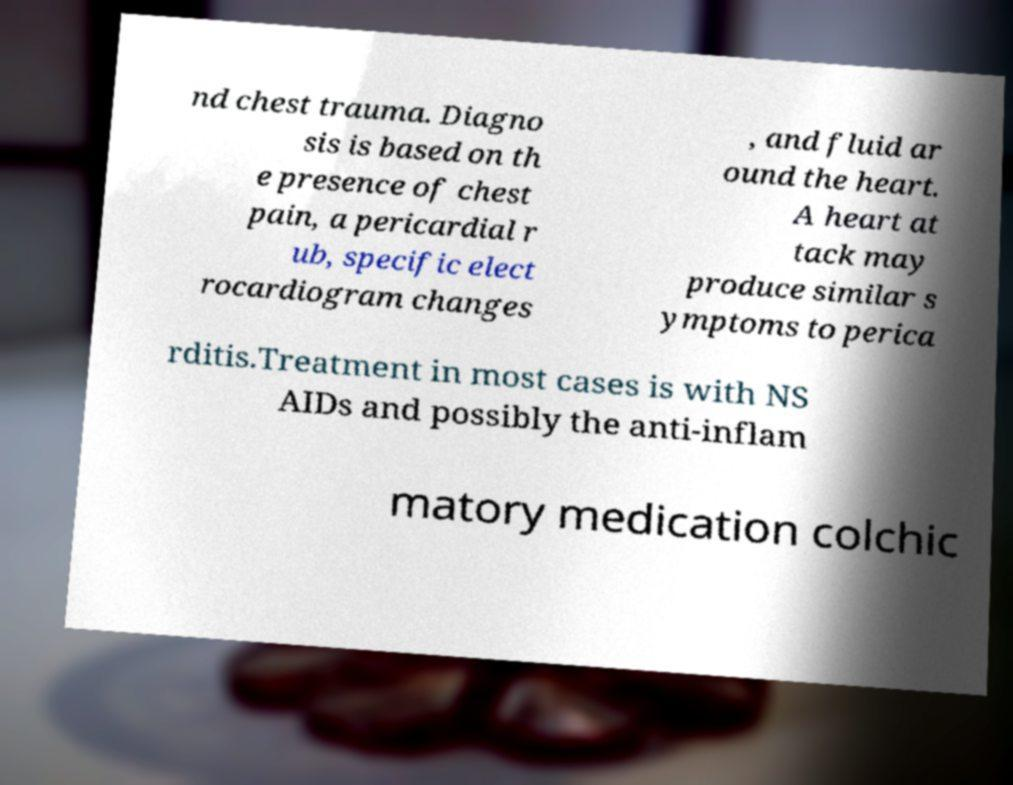Please read and relay the text visible in this image. What does it say? nd chest trauma. Diagno sis is based on th e presence of chest pain, a pericardial r ub, specific elect rocardiogram changes , and fluid ar ound the heart. A heart at tack may produce similar s ymptoms to perica rditis.Treatment in most cases is with NS AIDs and possibly the anti-inflam matory medication colchic 